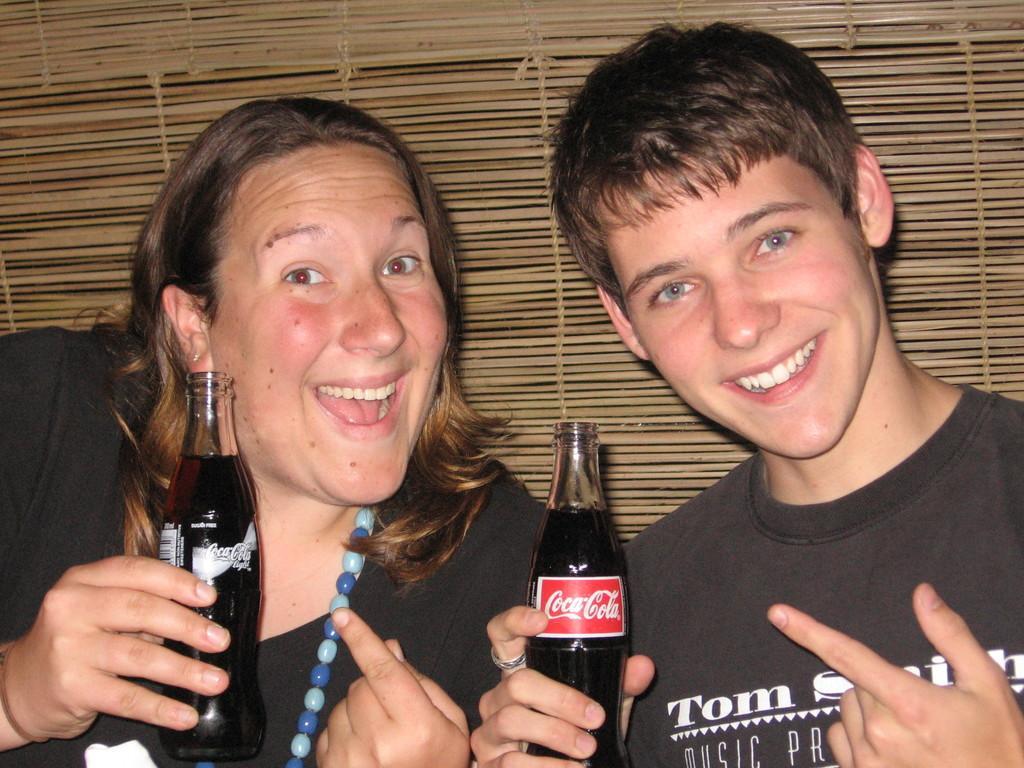Can you describe this image briefly? This picture shows a woman and a boy holding a drink bottles in their hands and smiling. In the background there is a wooden curtain here. 